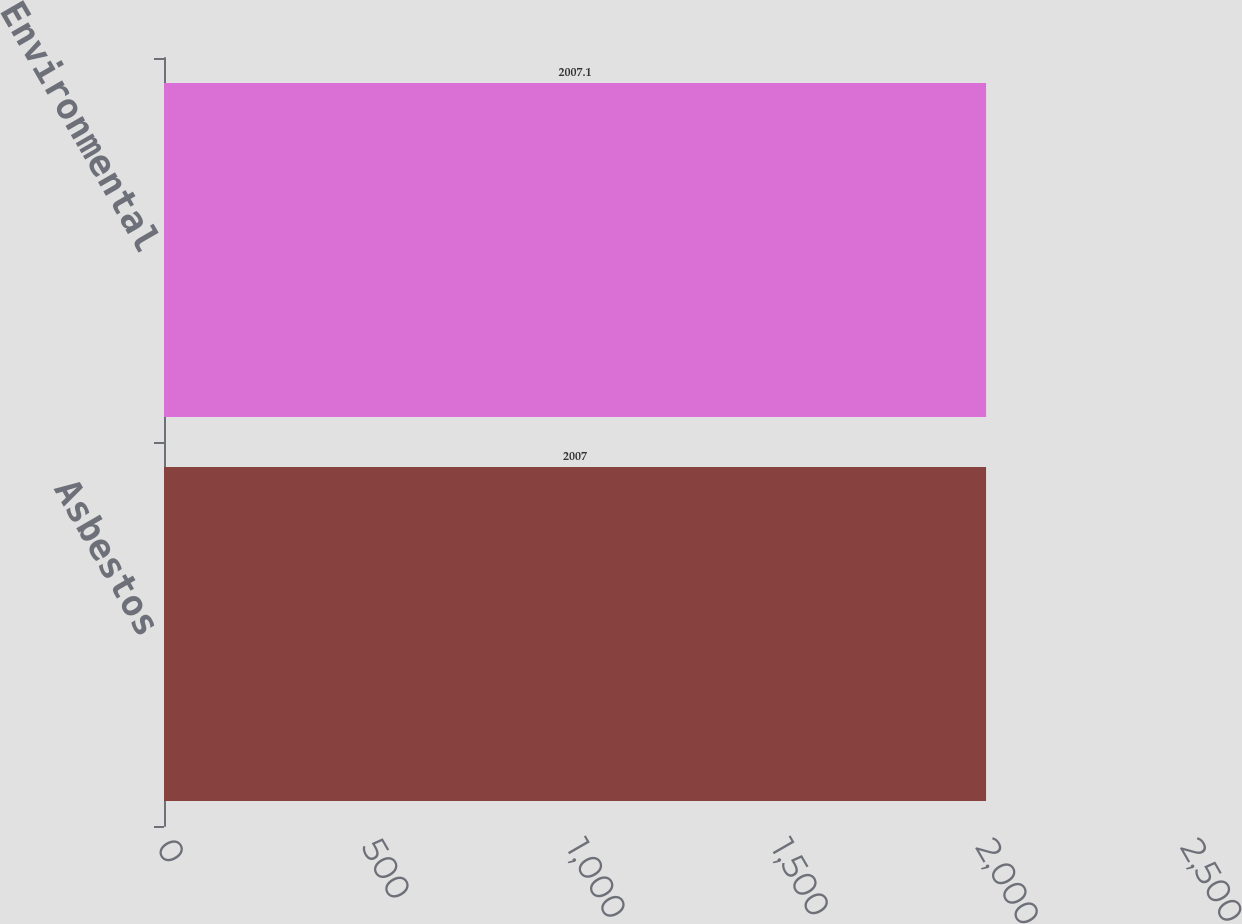<chart> <loc_0><loc_0><loc_500><loc_500><bar_chart><fcel>Asbestos<fcel>Environmental<nl><fcel>2007<fcel>2007.1<nl></chart> 